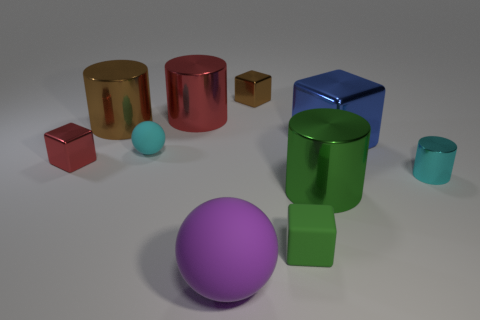Subtract 2 cylinders. How many cylinders are left? 2 Subtract all purple cubes. Subtract all red cylinders. How many cubes are left? 4 Subtract all cylinders. How many objects are left? 6 Subtract 0 gray cylinders. How many objects are left? 10 Subtract all small cylinders. Subtract all purple matte things. How many objects are left? 8 Add 8 blue things. How many blue things are left? 9 Add 6 small brown metal blocks. How many small brown metal blocks exist? 7 